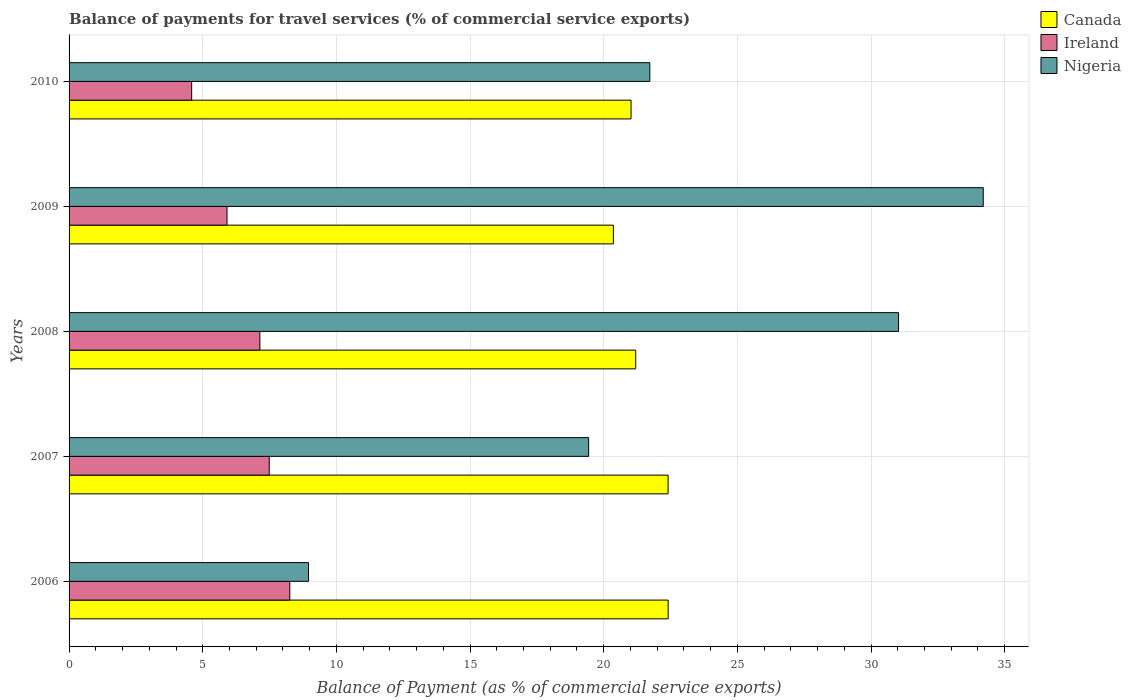How many different coloured bars are there?
Offer a terse response. 3. How many groups of bars are there?
Make the answer very short. 5. Are the number of bars per tick equal to the number of legend labels?
Your answer should be compact. Yes. Are the number of bars on each tick of the Y-axis equal?
Offer a terse response. Yes. What is the label of the 4th group of bars from the top?
Your answer should be compact. 2007. In how many cases, is the number of bars for a given year not equal to the number of legend labels?
Give a very brief answer. 0. What is the balance of payments for travel services in Canada in 2007?
Your answer should be very brief. 22.41. Across all years, what is the maximum balance of payments for travel services in Nigeria?
Provide a short and direct response. 34.2. Across all years, what is the minimum balance of payments for travel services in Nigeria?
Provide a succinct answer. 8.96. In which year was the balance of payments for travel services in Nigeria maximum?
Offer a very short reply. 2009. What is the total balance of payments for travel services in Canada in the graph?
Provide a short and direct response. 107.4. What is the difference between the balance of payments for travel services in Ireland in 2006 and that in 2010?
Give a very brief answer. 3.67. What is the difference between the balance of payments for travel services in Nigeria in 2009 and the balance of payments for travel services in Canada in 2007?
Ensure brevity in your answer.  11.79. What is the average balance of payments for travel services in Canada per year?
Make the answer very short. 21.48. In the year 2009, what is the difference between the balance of payments for travel services in Canada and balance of payments for travel services in Ireland?
Your response must be concise. 14.45. In how many years, is the balance of payments for travel services in Nigeria greater than 14 %?
Offer a very short reply. 4. What is the ratio of the balance of payments for travel services in Ireland in 2007 to that in 2008?
Your answer should be very brief. 1.05. Is the balance of payments for travel services in Nigeria in 2007 less than that in 2009?
Offer a terse response. Yes. Is the difference between the balance of payments for travel services in Canada in 2008 and 2010 greater than the difference between the balance of payments for travel services in Ireland in 2008 and 2010?
Offer a very short reply. No. What is the difference between the highest and the second highest balance of payments for travel services in Ireland?
Offer a very short reply. 0.77. What is the difference between the highest and the lowest balance of payments for travel services in Canada?
Provide a succinct answer. 2.05. Is the sum of the balance of payments for travel services in Canada in 2006 and 2009 greater than the maximum balance of payments for travel services in Ireland across all years?
Your answer should be very brief. Yes. What does the 2nd bar from the top in 2007 represents?
Keep it short and to the point. Ireland. What does the 1st bar from the bottom in 2008 represents?
Make the answer very short. Canada. Does the graph contain any zero values?
Your response must be concise. No. Does the graph contain grids?
Your answer should be compact. Yes. How are the legend labels stacked?
Ensure brevity in your answer.  Vertical. What is the title of the graph?
Offer a very short reply. Balance of payments for travel services (% of commercial service exports). Does "Latin America(all income levels)" appear as one of the legend labels in the graph?
Your answer should be very brief. No. What is the label or title of the X-axis?
Provide a succinct answer. Balance of Payment (as % of commercial service exports). What is the label or title of the Y-axis?
Offer a very short reply. Years. What is the Balance of Payment (as % of commercial service exports) in Canada in 2006?
Offer a terse response. 22.41. What is the Balance of Payment (as % of commercial service exports) in Ireland in 2006?
Offer a terse response. 8.26. What is the Balance of Payment (as % of commercial service exports) in Nigeria in 2006?
Make the answer very short. 8.96. What is the Balance of Payment (as % of commercial service exports) in Canada in 2007?
Offer a terse response. 22.41. What is the Balance of Payment (as % of commercial service exports) of Ireland in 2007?
Ensure brevity in your answer.  7.49. What is the Balance of Payment (as % of commercial service exports) of Nigeria in 2007?
Give a very brief answer. 19.44. What is the Balance of Payment (as % of commercial service exports) in Canada in 2008?
Provide a short and direct response. 21.2. What is the Balance of Payment (as % of commercial service exports) in Ireland in 2008?
Provide a succinct answer. 7.14. What is the Balance of Payment (as % of commercial service exports) in Nigeria in 2008?
Give a very brief answer. 31.03. What is the Balance of Payment (as % of commercial service exports) in Canada in 2009?
Ensure brevity in your answer.  20.36. What is the Balance of Payment (as % of commercial service exports) in Ireland in 2009?
Your answer should be very brief. 5.91. What is the Balance of Payment (as % of commercial service exports) in Nigeria in 2009?
Ensure brevity in your answer.  34.2. What is the Balance of Payment (as % of commercial service exports) in Canada in 2010?
Provide a succinct answer. 21.02. What is the Balance of Payment (as % of commercial service exports) in Ireland in 2010?
Keep it short and to the point. 4.59. What is the Balance of Payment (as % of commercial service exports) of Nigeria in 2010?
Offer a very short reply. 21.73. Across all years, what is the maximum Balance of Payment (as % of commercial service exports) in Canada?
Make the answer very short. 22.41. Across all years, what is the maximum Balance of Payment (as % of commercial service exports) in Ireland?
Give a very brief answer. 8.26. Across all years, what is the maximum Balance of Payment (as % of commercial service exports) of Nigeria?
Your response must be concise. 34.2. Across all years, what is the minimum Balance of Payment (as % of commercial service exports) in Canada?
Your answer should be compact. 20.36. Across all years, what is the minimum Balance of Payment (as % of commercial service exports) of Ireland?
Make the answer very short. 4.59. Across all years, what is the minimum Balance of Payment (as % of commercial service exports) in Nigeria?
Provide a short and direct response. 8.96. What is the total Balance of Payment (as % of commercial service exports) of Canada in the graph?
Provide a short and direct response. 107.4. What is the total Balance of Payment (as % of commercial service exports) of Ireland in the graph?
Give a very brief answer. 33.37. What is the total Balance of Payment (as % of commercial service exports) of Nigeria in the graph?
Your response must be concise. 115.34. What is the difference between the Balance of Payment (as % of commercial service exports) in Canada in 2006 and that in 2007?
Ensure brevity in your answer.  0. What is the difference between the Balance of Payment (as % of commercial service exports) of Ireland in 2006 and that in 2007?
Make the answer very short. 0.77. What is the difference between the Balance of Payment (as % of commercial service exports) of Nigeria in 2006 and that in 2007?
Keep it short and to the point. -10.48. What is the difference between the Balance of Payment (as % of commercial service exports) in Canada in 2006 and that in 2008?
Your response must be concise. 1.21. What is the difference between the Balance of Payment (as % of commercial service exports) of Ireland in 2006 and that in 2008?
Offer a very short reply. 1.12. What is the difference between the Balance of Payment (as % of commercial service exports) in Nigeria in 2006 and that in 2008?
Your answer should be very brief. -22.07. What is the difference between the Balance of Payment (as % of commercial service exports) of Canada in 2006 and that in 2009?
Provide a succinct answer. 2.05. What is the difference between the Balance of Payment (as % of commercial service exports) in Ireland in 2006 and that in 2009?
Make the answer very short. 2.35. What is the difference between the Balance of Payment (as % of commercial service exports) in Nigeria in 2006 and that in 2009?
Give a very brief answer. -25.24. What is the difference between the Balance of Payment (as % of commercial service exports) of Canada in 2006 and that in 2010?
Your answer should be very brief. 1.39. What is the difference between the Balance of Payment (as % of commercial service exports) in Ireland in 2006 and that in 2010?
Offer a terse response. 3.67. What is the difference between the Balance of Payment (as % of commercial service exports) of Nigeria in 2006 and that in 2010?
Your answer should be very brief. -12.77. What is the difference between the Balance of Payment (as % of commercial service exports) of Canada in 2007 and that in 2008?
Make the answer very short. 1.21. What is the difference between the Balance of Payment (as % of commercial service exports) in Ireland in 2007 and that in 2008?
Your answer should be very brief. 0.35. What is the difference between the Balance of Payment (as % of commercial service exports) of Nigeria in 2007 and that in 2008?
Provide a succinct answer. -11.59. What is the difference between the Balance of Payment (as % of commercial service exports) in Canada in 2007 and that in 2009?
Give a very brief answer. 2.05. What is the difference between the Balance of Payment (as % of commercial service exports) in Ireland in 2007 and that in 2009?
Keep it short and to the point. 1.58. What is the difference between the Balance of Payment (as % of commercial service exports) in Nigeria in 2007 and that in 2009?
Your answer should be very brief. -14.76. What is the difference between the Balance of Payment (as % of commercial service exports) in Canada in 2007 and that in 2010?
Make the answer very short. 1.39. What is the difference between the Balance of Payment (as % of commercial service exports) of Ireland in 2007 and that in 2010?
Make the answer very short. 2.9. What is the difference between the Balance of Payment (as % of commercial service exports) of Nigeria in 2007 and that in 2010?
Provide a succinct answer. -2.29. What is the difference between the Balance of Payment (as % of commercial service exports) in Canada in 2008 and that in 2009?
Keep it short and to the point. 0.84. What is the difference between the Balance of Payment (as % of commercial service exports) in Ireland in 2008 and that in 2009?
Make the answer very short. 1.23. What is the difference between the Balance of Payment (as % of commercial service exports) in Nigeria in 2008 and that in 2009?
Keep it short and to the point. -3.17. What is the difference between the Balance of Payment (as % of commercial service exports) of Canada in 2008 and that in 2010?
Your answer should be very brief. 0.17. What is the difference between the Balance of Payment (as % of commercial service exports) of Ireland in 2008 and that in 2010?
Your response must be concise. 2.55. What is the difference between the Balance of Payment (as % of commercial service exports) of Nigeria in 2008 and that in 2010?
Ensure brevity in your answer.  9.3. What is the difference between the Balance of Payment (as % of commercial service exports) in Canada in 2009 and that in 2010?
Keep it short and to the point. -0.66. What is the difference between the Balance of Payment (as % of commercial service exports) of Ireland in 2009 and that in 2010?
Keep it short and to the point. 1.32. What is the difference between the Balance of Payment (as % of commercial service exports) of Nigeria in 2009 and that in 2010?
Provide a short and direct response. 12.47. What is the difference between the Balance of Payment (as % of commercial service exports) in Canada in 2006 and the Balance of Payment (as % of commercial service exports) in Ireland in 2007?
Keep it short and to the point. 14.92. What is the difference between the Balance of Payment (as % of commercial service exports) in Canada in 2006 and the Balance of Payment (as % of commercial service exports) in Nigeria in 2007?
Make the answer very short. 2.97. What is the difference between the Balance of Payment (as % of commercial service exports) in Ireland in 2006 and the Balance of Payment (as % of commercial service exports) in Nigeria in 2007?
Ensure brevity in your answer.  -11.18. What is the difference between the Balance of Payment (as % of commercial service exports) of Canada in 2006 and the Balance of Payment (as % of commercial service exports) of Ireland in 2008?
Provide a succinct answer. 15.27. What is the difference between the Balance of Payment (as % of commercial service exports) of Canada in 2006 and the Balance of Payment (as % of commercial service exports) of Nigeria in 2008?
Your response must be concise. -8.62. What is the difference between the Balance of Payment (as % of commercial service exports) in Ireland in 2006 and the Balance of Payment (as % of commercial service exports) in Nigeria in 2008?
Provide a short and direct response. -22.77. What is the difference between the Balance of Payment (as % of commercial service exports) of Canada in 2006 and the Balance of Payment (as % of commercial service exports) of Ireland in 2009?
Your answer should be compact. 16.5. What is the difference between the Balance of Payment (as % of commercial service exports) in Canada in 2006 and the Balance of Payment (as % of commercial service exports) in Nigeria in 2009?
Keep it short and to the point. -11.79. What is the difference between the Balance of Payment (as % of commercial service exports) of Ireland in 2006 and the Balance of Payment (as % of commercial service exports) of Nigeria in 2009?
Provide a succinct answer. -25.94. What is the difference between the Balance of Payment (as % of commercial service exports) in Canada in 2006 and the Balance of Payment (as % of commercial service exports) in Ireland in 2010?
Your answer should be compact. 17.83. What is the difference between the Balance of Payment (as % of commercial service exports) of Canada in 2006 and the Balance of Payment (as % of commercial service exports) of Nigeria in 2010?
Give a very brief answer. 0.69. What is the difference between the Balance of Payment (as % of commercial service exports) in Ireland in 2006 and the Balance of Payment (as % of commercial service exports) in Nigeria in 2010?
Your answer should be very brief. -13.47. What is the difference between the Balance of Payment (as % of commercial service exports) in Canada in 2007 and the Balance of Payment (as % of commercial service exports) in Ireland in 2008?
Make the answer very short. 15.27. What is the difference between the Balance of Payment (as % of commercial service exports) in Canada in 2007 and the Balance of Payment (as % of commercial service exports) in Nigeria in 2008?
Offer a very short reply. -8.62. What is the difference between the Balance of Payment (as % of commercial service exports) of Ireland in 2007 and the Balance of Payment (as % of commercial service exports) of Nigeria in 2008?
Make the answer very short. -23.54. What is the difference between the Balance of Payment (as % of commercial service exports) in Canada in 2007 and the Balance of Payment (as % of commercial service exports) in Ireland in 2009?
Give a very brief answer. 16.5. What is the difference between the Balance of Payment (as % of commercial service exports) in Canada in 2007 and the Balance of Payment (as % of commercial service exports) in Nigeria in 2009?
Provide a short and direct response. -11.79. What is the difference between the Balance of Payment (as % of commercial service exports) of Ireland in 2007 and the Balance of Payment (as % of commercial service exports) of Nigeria in 2009?
Provide a succinct answer. -26.71. What is the difference between the Balance of Payment (as % of commercial service exports) of Canada in 2007 and the Balance of Payment (as % of commercial service exports) of Ireland in 2010?
Provide a succinct answer. 17.82. What is the difference between the Balance of Payment (as % of commercial service exports) in Canada in 2007 and the Balance of Payment (as % of commercial service exports) in Nigeria in 2010?
Provide a short and direct response. 0.68. What is the difference between the Balance of Payment (as % of commercial service exports) in Ireland in 2007 and the Balance of Payment (as % of commercial service exports) in Nigeria in 2010?
Your answer should be compact. -14.24. What is the difference between the Balance of Payment (as % of commercial service exports) in Canada in 2008 and the Balance of Payment (as % of commercial service exports) in Ireland in 2009?
Ensure brevity in your answer.  15.29. What is the difference between the Balance of Payment (as % of commercial service exports) in Canada in 2008 and the Balance of Payment (as % of commercial service exports) in Nigeria in 2009?
Give a very brief answer. -13. What is the difference between the Balance of Payment (as % of commercial service exports) in Ireland in 2008 and the Balance of Payment (as % of commercial service exports) in Nigeria in 2009?
Offer a terse response. -27.06. What is the difference between the Balance of Payment (as % of commercial service exports) of Canada in 2008 and the Balance of Payment (as % of commercial service exports) of Ireland in 2010?
Your answer should be very brief. 16.61. What is the difference between the Balance of Payment (as % of commercial service exports) of Canada in 2008 and the Balance of Payment (as % of commercial service exports) of Nigeria in 2010?
Give a very brief answer. -0.53. What is the difference between the Balance of Payment (as % of commercial service exports) in Ireland in 2008 and the Balance of Payment (as % of commercial service exports) in Nigeria in 2010?
Your response must be concise. -14.59. What is the difference between the Balance of Payment (as % of commercial service exports) of Canada in 2009 and the Balance of Payment (as % of commercial service exports) of Ireland in 2010?
Your answer should be compact. 15.77. What is the difference between the Balance of Payment (as % of commercial service exports) in Canada in 2009 and the Balance of Payment (as % of commercial service exports) in Nigeria in 2010?
Your answer should be very brief. -1.36. What is the difference between the Balance of Payment (as % of commercial service exports) of Ireland in 2009 and the Balance of Payment (as % of commercial service exports) of Nigeria in 2010?
Your answer should be compact. -15.82. What is the average Balance of Payment (as % of commercial service exports) in Canada per year?
Give a very brief answer. 21.48. What is the average Balance of Payment (as % of commercial service exports) in Ireland per year?
Give a very brief answer. 6.67. What is the average Balance of Payment (as % of commercial service exports) of Nigeria per year?
Give a very brief answer. 23.07. In the year 2006, what is the difference between the Balance of Payment (as % of commercial service exports) in Canada and Balance of Payment (as % of commercial service exports) in Ireland?
Provide a succinct answer. 14.15. In the year 2006, what is the difference between the Balance of Payment (as % of commercial service exports) of Canada and Balance of Payment (as % of commercial service exports) of Nigeria?
Give a very brief answer. 13.46. In the year 2006, what is the difference between the Balance of Payment (as % of commercial service exports) of Ireland and Balance of Payment (as % of commercial service exports) of Nigeria?
Ensure brevity in your answer.  -0.7. In the year 2007, what is the difference between the Balance of Payment (as % of commercial service exports) in Canada and Balance of Payment (as % of commercial service exports) in Ireland?
Your response must be concise. 14.92. In the year 2007, what is the difference between the Balance of Payment (as % of commercial service exports) of Canada and Balance of Payment (as % of commercial service exports) of Nigeria?
Make the answer very short. 2.97. In the year 2007, what is the difference between the Balance of Payment (as % of commercial service exports) in Ireland and Balance of Payment (as % of commercial service exports) in Nigeria?
Offer a very short reply. -11.95. In the year 2008, what is the difference between the Balance of Payment (as % of commercial service exports) in Canada and Balance of Payment (as % of commercial service exports) in Ireland?
Give a very brief answer. 14.06. In the year 2008, what is the difference between the Balance of Payment (as % of commercial service exports) of Canada and Balance of Payment (as % of commercial service exports) of Nigeria?
Your response must be concise. -9.83. In the year 2008, what is the difference between the Balance of Payment (as % of commercial service exports) in Ireland and Balance of Payment (as % of commercial service exports) in Nigeria?
Provide a short and direct response. -23.89. In the year 2009, what is the difference between the Balance of Payment (as % of commercial service exports) of Canada and Balance of Payment (as % of commercial service exports) of Ireland?
Provide a succinct answer. 14.45. In the year 2009, what is the difference between the Balance of Payment (as % of commercial service exports) in Canada and Balance of Payment (as % of commercial service exports) in Nigeria?
Your answer should be compact. -13.84. In the year 2009, what is the difference between the Balance of Payment (as % of commercial service exports) in Ireland and Balance of Payment (as % of commercial service exports) in Nigeria?
Give a very brief answer. -28.29. In the year 2010, what is the difference between the Balance of Payment (as % of commercial service exports) of Canada and Balance of Payment (as % of commercial service exports) of Ireland?
Give a very brief answer. 16.44. In the year 2010, what is the difference between the Balance of Payment (as % of commercial service exports) in Canada and Balance of Payment (as % of commercial service exports) in Nigeria?
Your response must be concise. -0.7. In the year 2010, what is the difference between the Balance of Payment (as % of commercial service exports) in Ireland and Balance of Payment (as % of commercial service exports) in Nigeria?
Your response must be concise. -17.14. What is the ratio of the Balance of Payment (as % of commercial service exports) of Canada in 2006 to that in 2007?
Give a very brief answer. 1. What is the ratio of the Balance of Payment (as % of commercial service exports) of Ireland in 2006 to that in 2007?
Provide a succinct answer. 1.1. What is the ratio of the Balance of Payment (as % of commercial service exports) of Nigeria in 2006 to that in 2007?
Offer a very short reply. 0.46. What is the ratio of the Balance of Payment (as % of commercial service exports) of Canada in 2006 to that in 2008?
Provide a succinct answer. 1.06. What is the ratio of the Balance of Payment (as % of commercial service exports) in Ireland in 2006 to that in 2008?
Provide a short and direct response. 1.16. What is the ratio of the Balance of Payment (as % of commercial service exports) in Nigeria in 2006 to that in 2008?
Offer a very short reply. 0.29. What is the ratio of the Balance of Payment (as % of commercial service exports) of Canada in 2006 to that in 2009?
Ensure brevity in your answer.  1.1. What is the ratio of the Balance of Payment (as % of commercial service exports) of Ireland in 2006 to that in 2009?
Provide a succinct answer. 1.4. What is the ratio of the Balance of Payment (as % of commercial service exports) in Nigeria in 2006 to that in 2009?
Give a very brief answer. 0.26. What is the ratio of the Balance of Payment (as % of commercial service exports) of Canada in 2006 to that in 2010?
Make the answer very short. 1.07. What is the ratio of the Balance of Payment (as % of commercial service exports) in Ireland in 2006 to that in 2010?
Give a very brief answer. 1.8. What is the ratio of the Balance of Payment (as % of commercial service exports) of Nigeria in 2006 to that in 2010?
Give a very brief answer. 0.41. What is the ratio of the Balance of Payment (as % of commercial service exports) of Canada in 2007 to that in 2008?
Provide a short and direct response. 1.06. What is the ratio of the Balance of Payment (as % of commercial service exports) in Ireland in 2007 to that in 2008?
Your answer should be compact. 1.05. What is the ratio of the Balance of Payment (as % of commercial service exports) of Nigeria in 2007 to that in 2008?
Your response must be concise. 0.63. What is the ratio of the Balance of Payment (as % of commercial service exports) in Canada in 2007 to that in 2009?
Ensure brevity in your answer.  1.1. What is the ratio of the Balance of Payment (as % of commercial service exports) of Ireland in 2007 to that in 2009?
Ensure brevity in your answer.  1.27. What is the ratio of the Balance of Payment (as % of commercial service exports) in Nigeria in 2007 to that in 2009?
Provide a succinct answer. 0.57. What is the ratio of the Balance of Payment (as % of commercial service exports) in Canada in 2007 to that in 2010?
Offer a terse response. 1.07. What is the ratio of the Balance of Payment (as % of commercial service exports) of Ireland in 2007 to that in 2010?
Your answer should be compact. 1.63. What is the ratio of the Balance of Payment (as % of commercial service exports) in Nigeria in 2007 to that in 2010?
Ensure brevity in your answer.  0.89. What is the ratio of the Balance of Payment (as % of commercial service exports) in Canada in 2008 to that in 2009?
Keep it short and to the point. 1.04. What is the ratio of the Balance of Payment (as % of commercial service exports) of Ireland in 2008 to that in 2009?
Make the answer very short. 1.21. What is the ratio of the Balance of Payment (as % of commercial service exports) in Nigeria in 2008 to that in 2009?
Give a very brief answer. 0.91. What is the ratio of the Balance of Payment (as % of commercial service exports) in Canada in 2008 to that in 2010?
Your answer should be very brief. 1.01. What is the ratio of the Balance of Payment (as % of commercial service exports) in Ireland in 2008 to that in 2010?
Make the answer very short. 1.56. What is the ratio of the Balance of Payment (as % of commercial service exports) in Nigeria in 2008 to that in 2010?
Your response must be concise. 1.43. What is the ratio of the Balance of Payment (as % of commercial service exports) of Canada in 2009 to that in 2010?
Your answer should be very brief. 0.97. What is the ratio of the Balance of Payment (as % of commercial service exports) in Ireland in 2009 to that in 2010?
Provide a short and direct response. 1.29. What is the ratio of the Balance of Payment (as % of commercial service exports) of Nigeria in 2009 to that in 2010?
Your answer should be compact. 1.57. What is the difference between the highest and the second highest Balance of Payment (as % of commercial service exports) in Canada?
Give a very brief answer. 0. What is the difference between the highest and the second highest Balance of Payment (as % of commercial service exports) of Ireland?
Offer a very short reply. 0.77. What is the difference between the highest and the second highest Balance of Payment (as % of commercial service exports) of Nigeria?
Your response must be concise. 3.17. What is the difference between the highest and the lowest Balance of Payment (as % of commercial service exports) in Canada?
Offer a very short reply. 2.05. What is the difference between the highest and the lowest Balance of Payment (as % of commercial service exports) of Ireland?
Make the answer very short. 3.67. What is the difference between the highest and the lowest Balance of Payment (as % of commercial service exports) in Nigeria?
Ensure brevity in your answer.  25.24. 